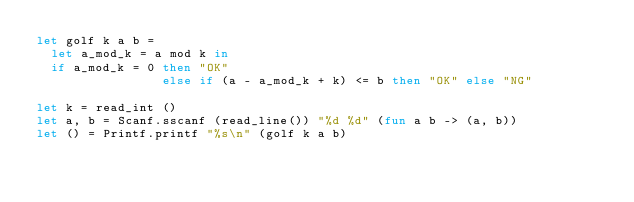<code> <loc_0><loc_0><loc_500><loc_500><_OCaml_>let golf k a b =
  let a_mod_k = a mod k in
  if a_mod_k = 0 then "OK"
                 else if (a - a_mod_k + k) <= b then "OK" else "NG"

let k = read_int ()
let a, b = Scanf.sscanf (read_line()) "%d %d" (fun a b -> (a, b))
let () = Printf.printf "%s\n" (golf k a b)</code> 